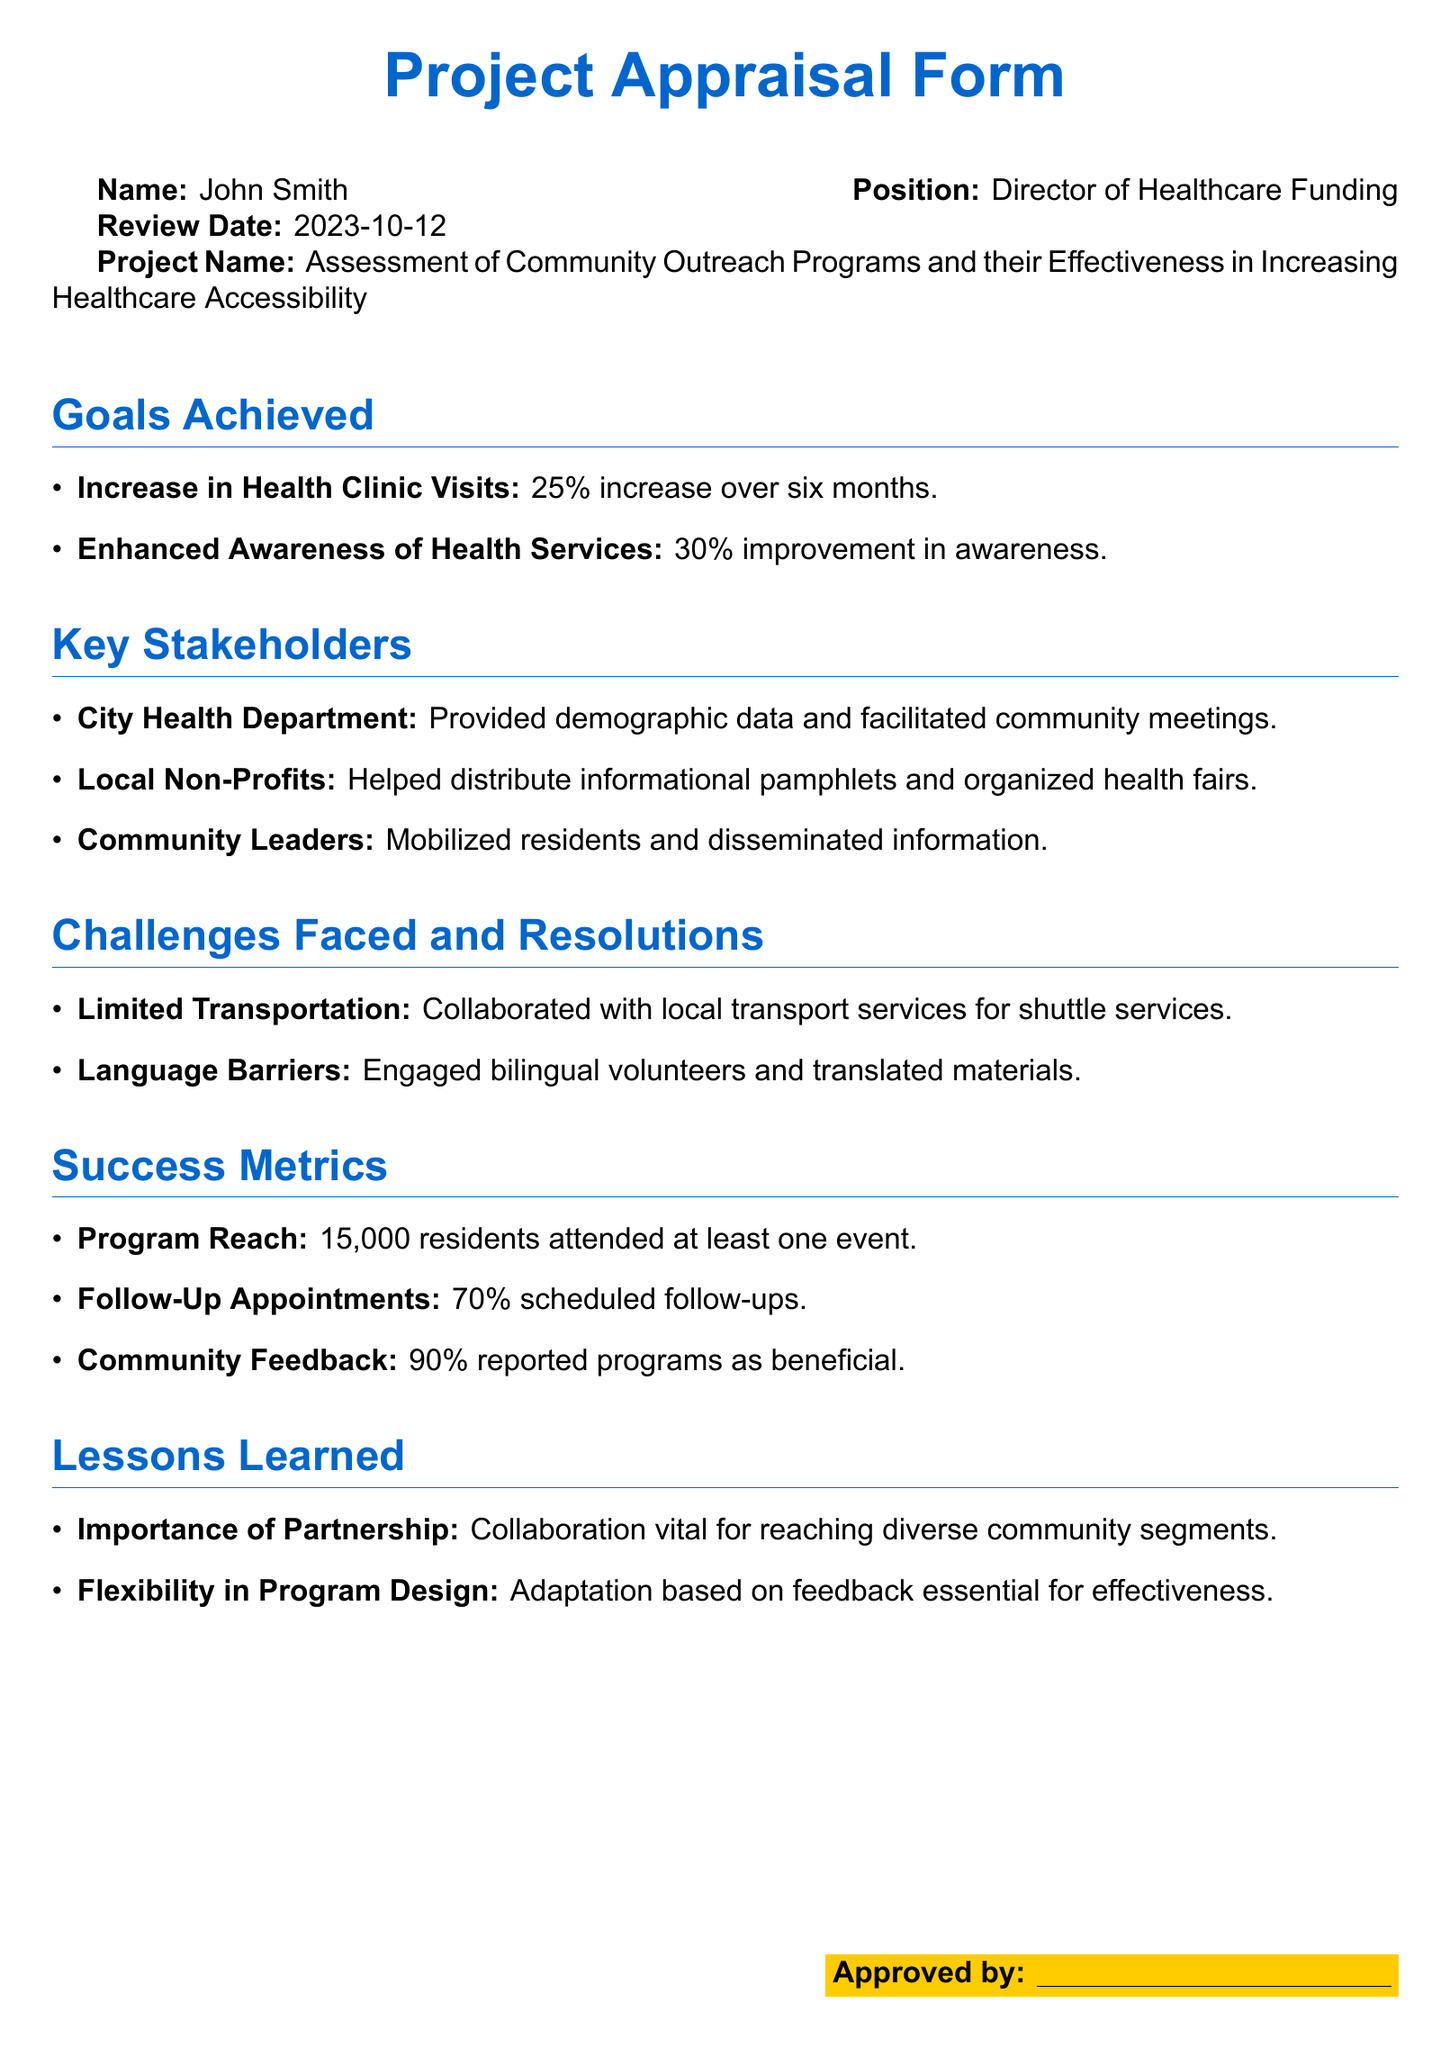What is the name of the project? The name of the project is stated clearly at the beginning of the document.
Answer: Assessment of Community Outreach Programs and their Effectiveness in Increasing Healthcare Accessibility Who is the Director of Healthcare Funding? The document lists the individual in this position, which provides a clear identification.
Answer: John Smith What was the percentage increase in health clinic visits? The increase in health clinic visits is highlighted as a specific achievement in the goals section.
Answer: 25% How many residents attended at least one event? This number is noted as a success metric to assess program reach in the document.
Answer: 15,000 residents What percentage of community feedback reported programs as beneficial? This information is provided in the success metrics section to gauge community satisfaction.
Answer: 90% What challenge was faced regarding transportation? The document specifies a limitation and outlines an associated resolution indicating the issue encountered.
Answer: Limited Transportation Which organization facilitated community meetings? The key stakeholders section names specific organizations involved in the project.
Answer: City Health Department What lesson highlighted the importance of collaboration? The lessons learned section enumerates the insights gained during the project, reflecting vital considerations.
Answer: Importance of Partnership 